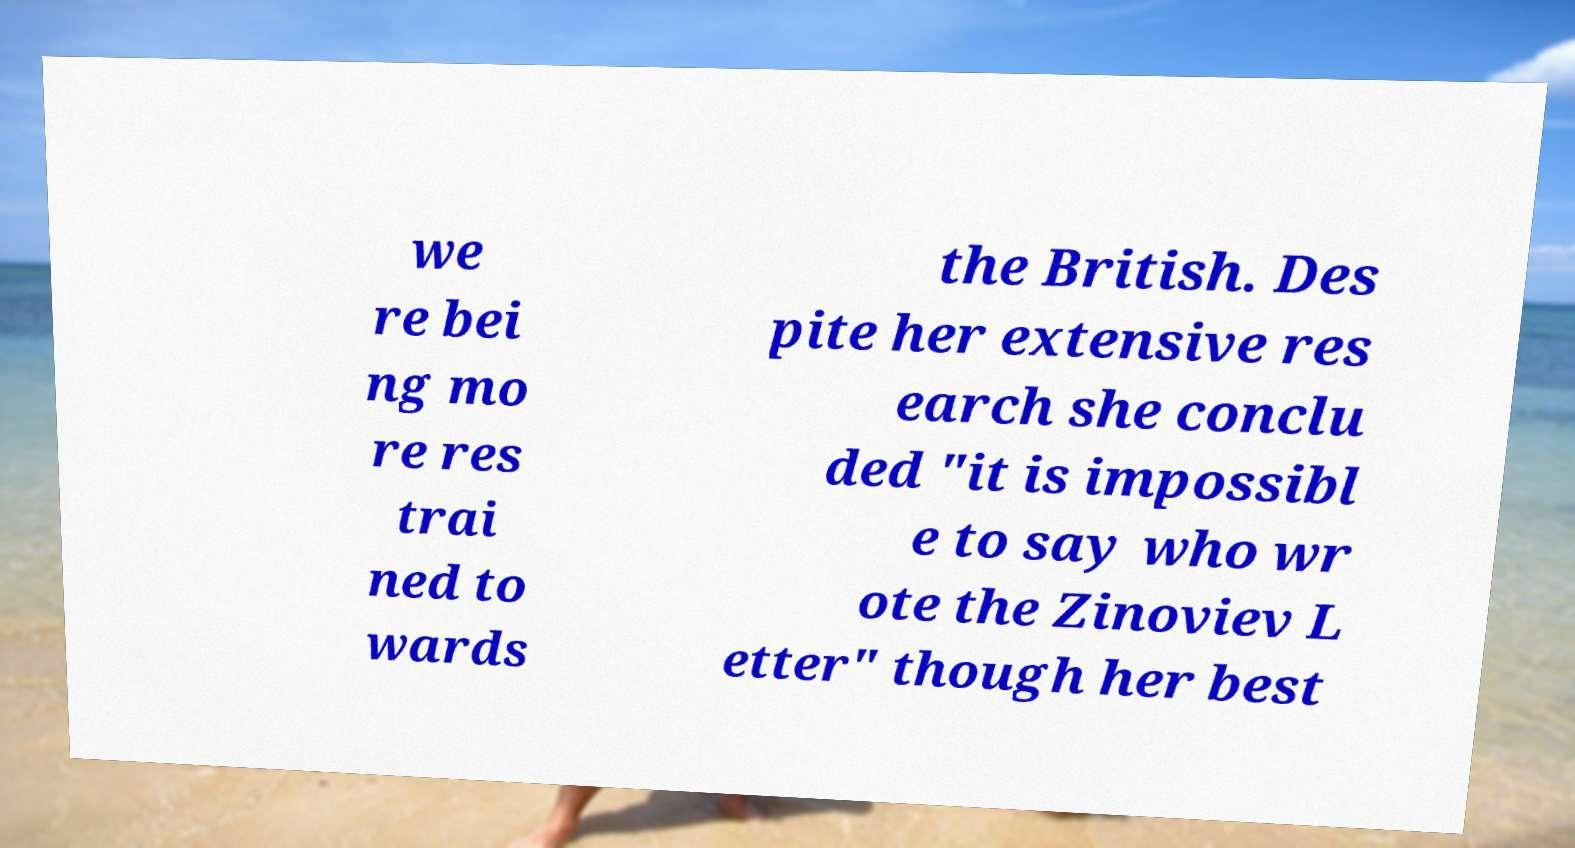Please identify and transcribe the text found in this image. we re bei ng mo re res trai ned to wards the British. Des pite her extensive res earch she conclu ded "it is impossibl e to say who wr ote the Zinoviev L etter" though her best 